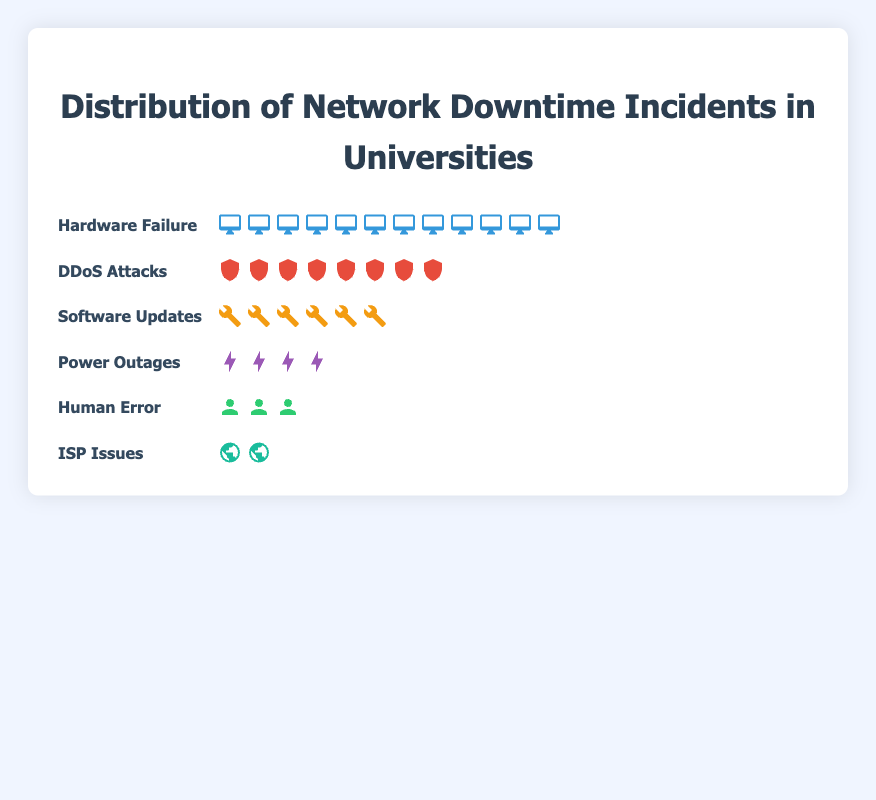what is the most common root cause of network downtime in universities? The plot shows the number of incidents for each root cause. By counting the icons, we see that Hardware Failure has the most incidents, with 12 icons representing it.
Answer: Hardware Failure How many incidents are caused by power outages? By looking at the Power Outages row, there are 4 lightning icons. Each icon represents one incident.
Answer: 4 Which root cause has the least incidents? The row showing ISP Issues has only 2 globe icons, indicating the fewest incidents compared to other causes.
Answer: ISP Issues How many more incidents are caused by Hardware Failure than Human Error? Hardware Failure has 12 incidents and Human Error has 3 incidents. The difference is 12 - 3 = 9.
Answer: 9 What is the total number of incidents caused by software updates and ddos attacks combined? Software Updates have 6 incidents and DDoS Attacks have 8 incidents. Adding them together gives 6 + 8 = 14.
Answer: 14 Which root cause has a count equal to half of the incidents caused by hardware failure? Hardware Failure has 12 incidents. Half of 12 is 6, which corresponds to the Software Updates row that has 6 wrench icons.
Answer: Software Updates What is the combined number of incidents caused by power outages and human error? Power Outages have 4 incidents and Human Error has 3 incidents. Adding them together gives 4 + 3 = 7.
Answer: 7 Is the number of incidents caused by ddos attacks greater than the incidents caused by power outages? DDoS Attacks have 8 incidents, and Power Outages have 4 incidents. Since 8 is greater than 4, the answer is yes.
Answer: Yes Rank the root causes from the highest to the lowest number of incidents. By looking at the number of icons for each root cause: Hardware Failure (12), DDoS Attacks (8), Software Updates (6), Power Outages (4), Human Error (3), ISP Issues (2).
Answer: Hardware Failure, DDoS Attacks, Software Updates, Power Outages, Human Error, ISP Issues 